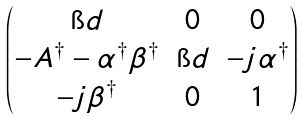Convert formula to latex. <formula><loc_0><loc_0><loc_500><loc_500>\begin{pmatrix} \i d & 0 & 0 \\ - A ^ { \dag } - \alpha ^ { \dag } \beta ^ { \dag } & \i d & - j \alpha ^ { \dag } \\ - j \beta ^ { \dag } & 0 & 1 \end{pmatrix}</formula> 